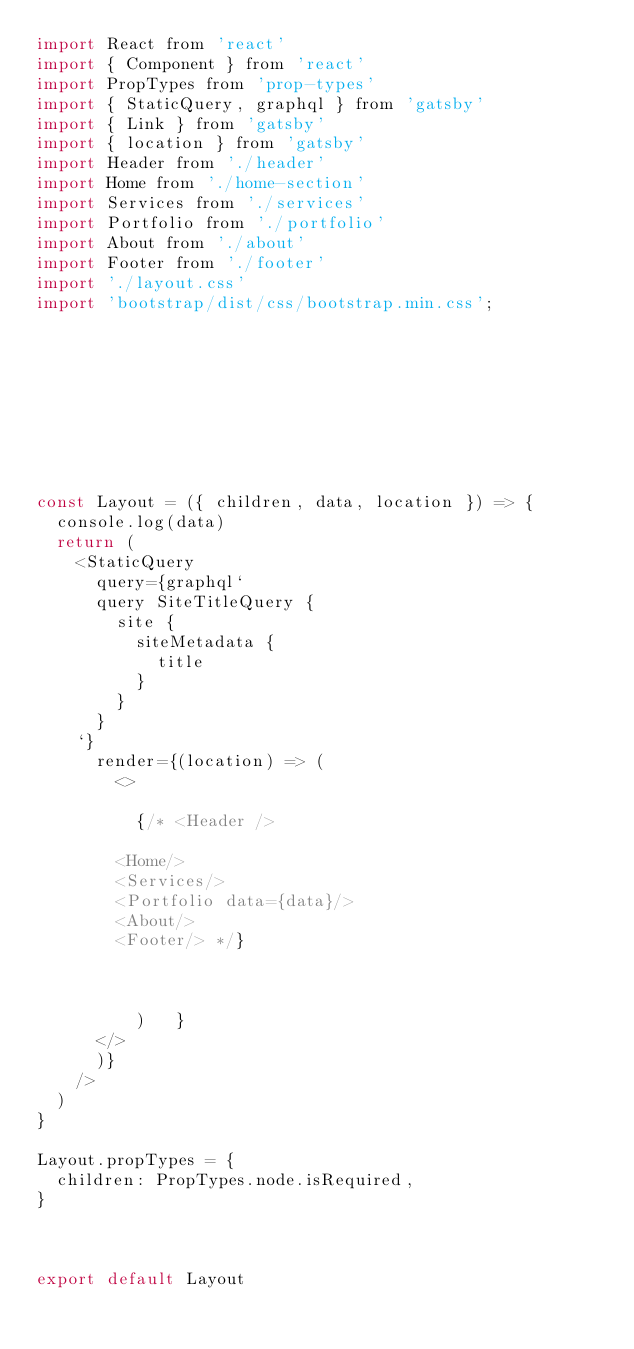<code> <loc_0><loc_0><loc_500><loc_500><_JavaScript_>import React from 'react'
import { Component } from 'react'
import PropTypes from 'prop-types'
import { StaticQuery, graphql } from 'gatsby'
import { Link } from 'gatsby'
import { location } from 'gatsby'
import Header from './header'
import Home from './home-section'
import Services from './services'
import Portfolio from './portfolio'
import About from './about'
import Footer from './footer'
import './layout.css'
import 'bootstrap/dist/css/bootstrap.min.css';









const Layout = ({ children, data, location }) => {
  console.log(data)
  return (
    <StaticQuery
      query={graphql`
      query SiteTitleQuery {
        site {
          siteMetadata {
            title
          }
        }
      }
    `}
      render={(location) => (
        <>

          {/* <Header />
        
        <Home/>
        <Services/>
        <Portfolio data={data}/>
        <About/>
        <Footer/> */}



          )   }
      </>
      )}
    />
  )
}

Layout.propTypes = {
  children: PropTypes.node.isRequired,
}



export default Layout
</code> 